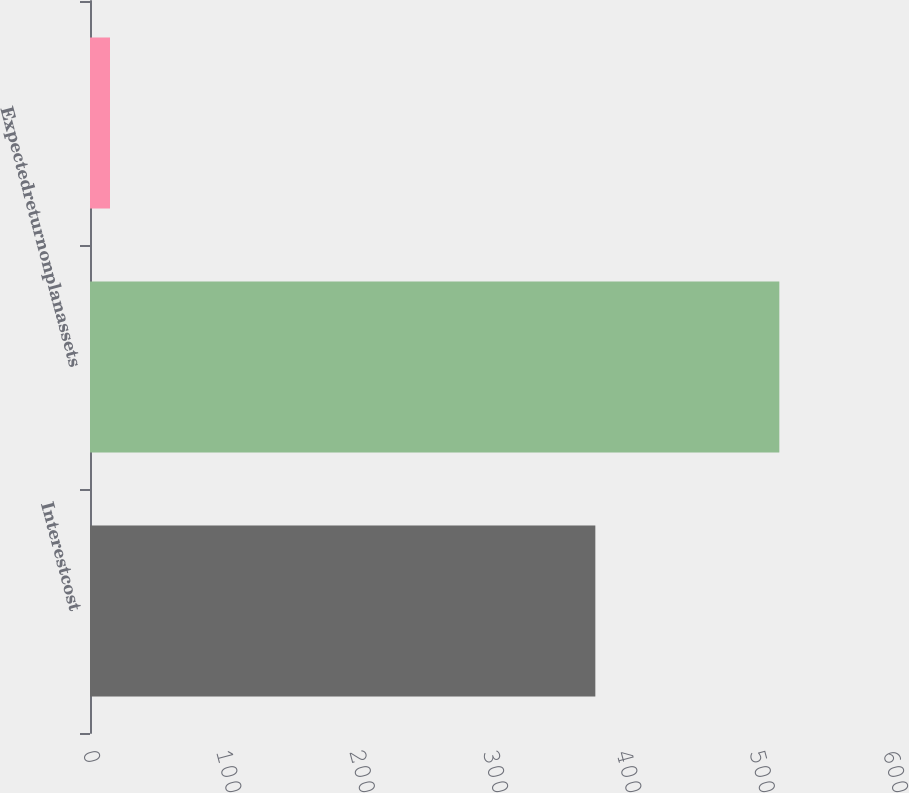Convert chart. <chart><loc_0><loc_0><loc_500><loc_500><bar_chart><fcel>Interestcost<fcel>Expectedreturnonplanassets<fcel>Unnamed: 2<nl><fcel>379<fcel>517<fcel>15<nl></chart> 